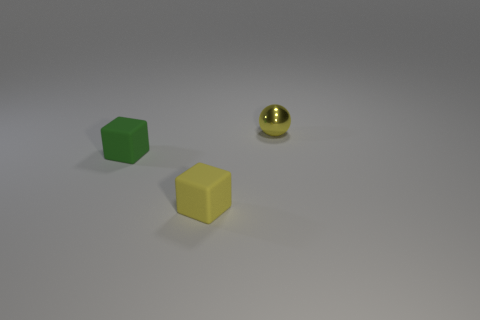Add 3 yellow objects. How many objects exist? 6 Subtract all blocks. How many objects are left? 1 Subtract all small yellow metallic things. Subtract all rubber objects. How many objects are left? 0 Add 2 tiny yellow matte blocks. How many tiny yellow matte blocks are left? 3 Add 1 green objects. How many green objects exist? 2 Subtract 0 red blocks. How many objects are left? 3 